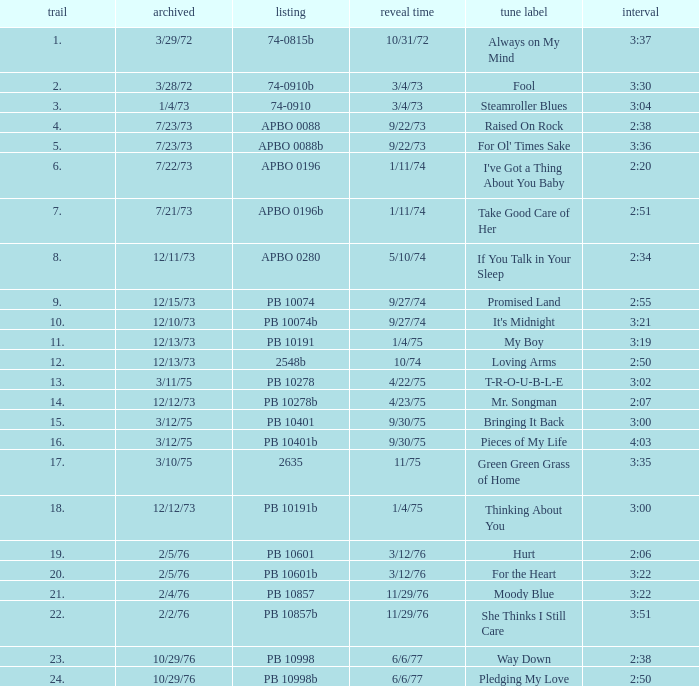Tell me the track that has the catalogue of apbo 0280 8.0. 